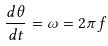<formula> <loc_0><loc_0><loc_500><loc_500>\frac { d \theta } { d t } = \omega = 2 \pi f</formula> 